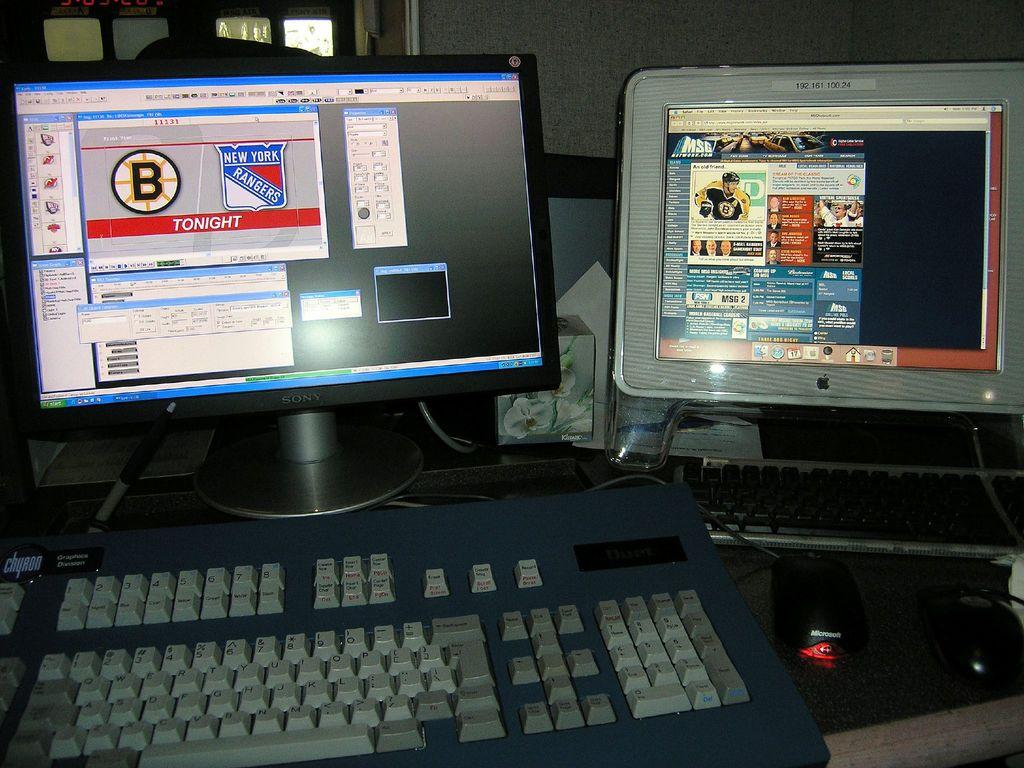<image>
Share a concise interpretation of the image provided. Twp computers are on a desk with images on their monitors, one promoting a New York Rangers game tonight. 